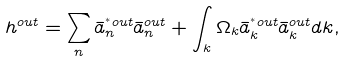Convert formula to latex. <formula><loc_0><loc_0><loc_500><loc_500>h ^ { o u t } = \sum _ { n } \bar { a } ^ { ^ { * } o u t } _ { n } \bar { a } ^ { o u t } _ { n } + \int _ { k } \Omega _ { k } \bar { a } ^ { ^ { * } o u t } _ { k } \bar { a } ^ { o u t } _ { k } d k ,</formula> 